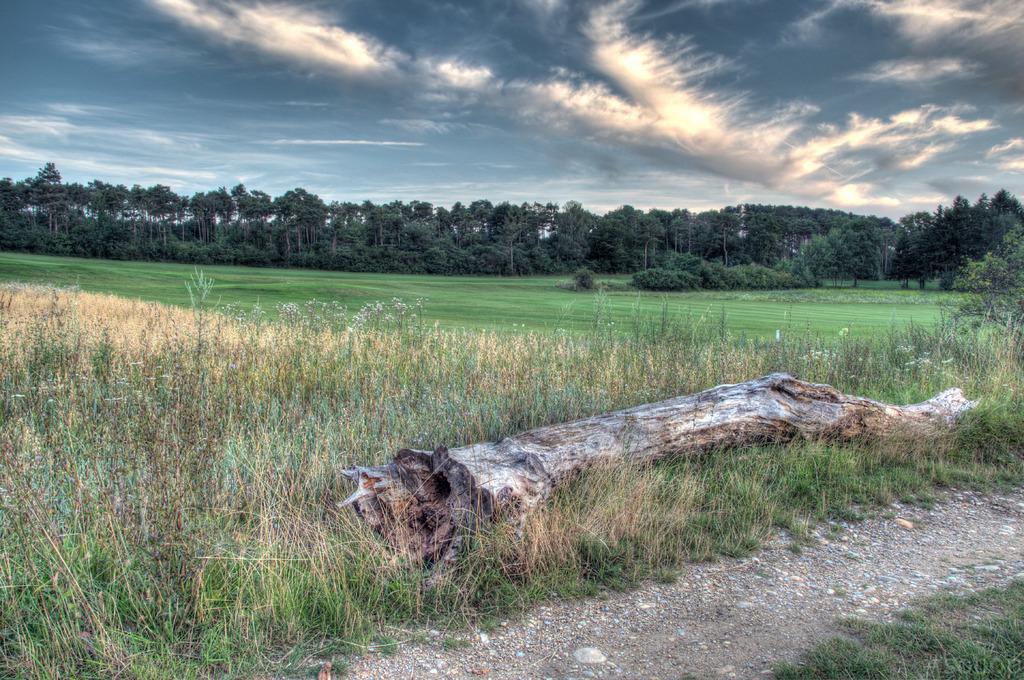Could you give a brief overview of what you see in this image? In the middle of the image we can see a wooden bark, in the background we can see few plants, trees and clouds. 